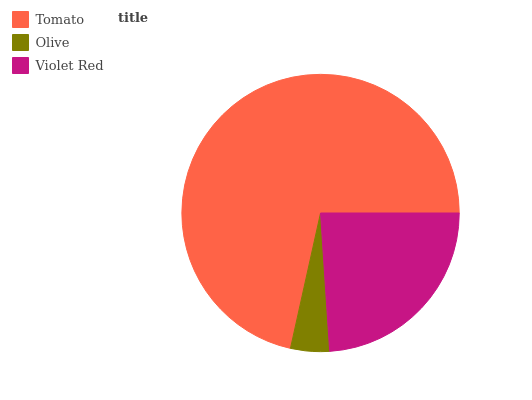Is Olive the minimum?
Answer yes or no. Yes. Is Tomato the maximum?
Answer yes or no. Yes. Is Violet Red the minimum?
Answer yes or no. No. Is Violet Red the maximum?
Answer yes or no. No. Is Violet Red greater than Olive?
Answer yes or no. Yes. Is Olive less than Violet Red?
Answer yes or no. Yes. Is Olive greater than Violet Red?
Answer yes or no. No. Is Violet Red less than Olive?
Answer yes or no. No. Is Violet Red the high median?
Answer yes or no. Yes. Is Violet Red the low median?
Answer yes or no. Yes. Is Tomato the high median?
Answer yes or no. No. Is Olive the low median?
Answer yes or no. No. 